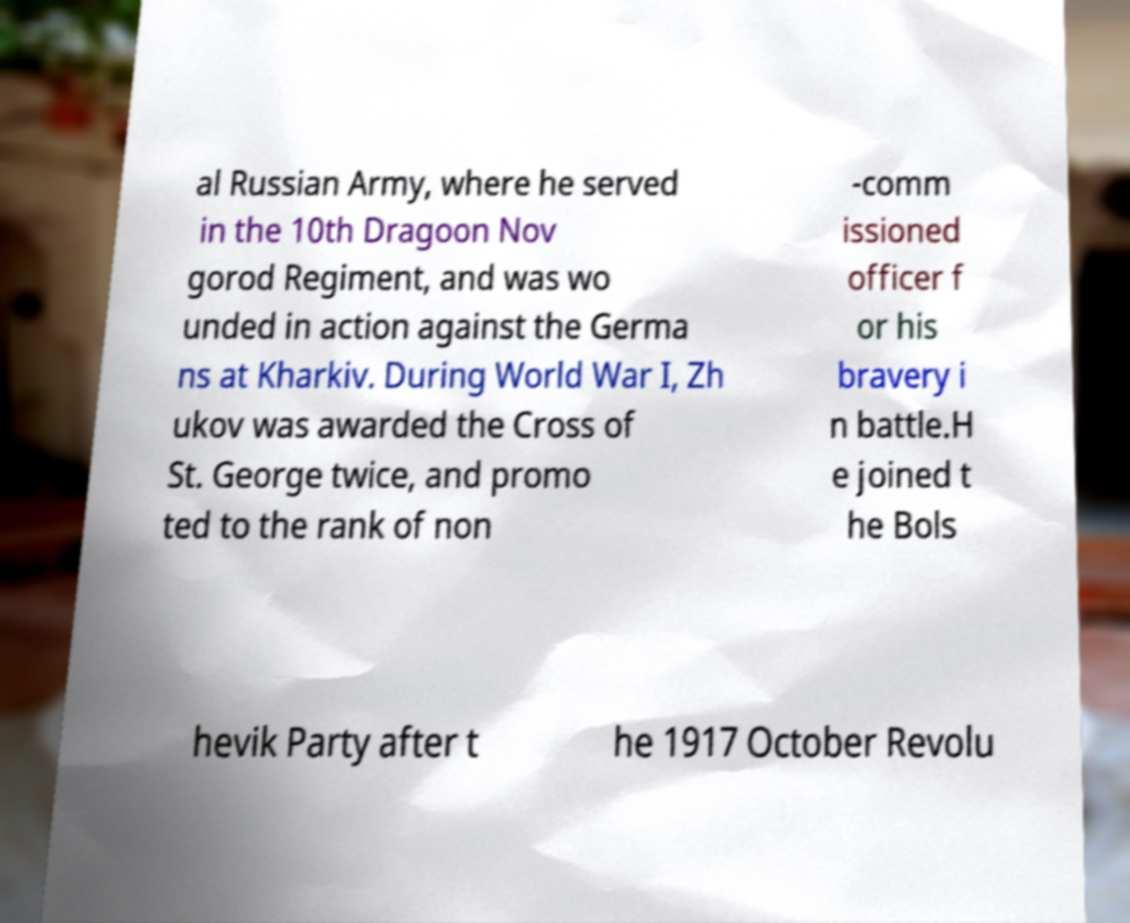Could you extract and type out the text from this image? al Russian Army, where he served in the 10th Dragoon Nov gorod Regiment, and was wo unded in action against the Germa ns at Kharkiv. During World War I, Zh ukov was awarded the Cross of St. George twice, and promo ted to the rank of non -comm issioned officer f or his bravery i n battle.H e joined t he Bols hevik Party after t he 1917 October Revolu 